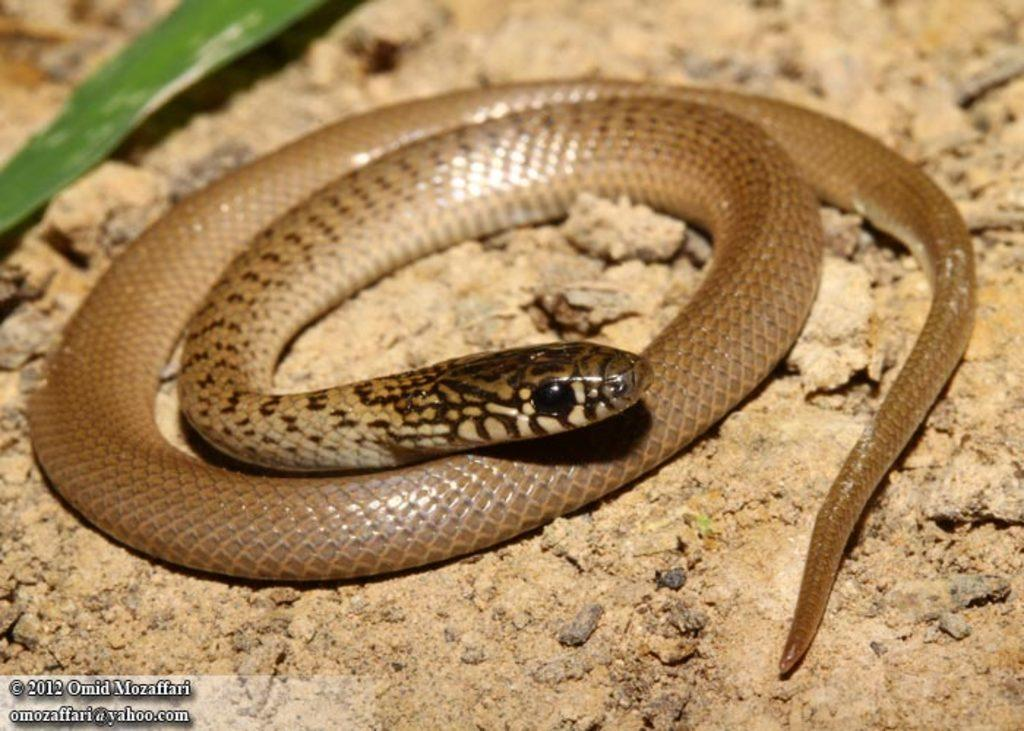What type of animal is in the image? There is a snake in the image. What color is the snake? The snake is brown in color. What is visible at the bottom of the image? There is ground visible at the bottom of the image. Where is the leaf located in the image? There is a leaf in the top left corner of the image. What type of sail can be seen on the snake's back in the image? There is no sail present in the image; it features a brown snake and a leaf in the top left corner. 